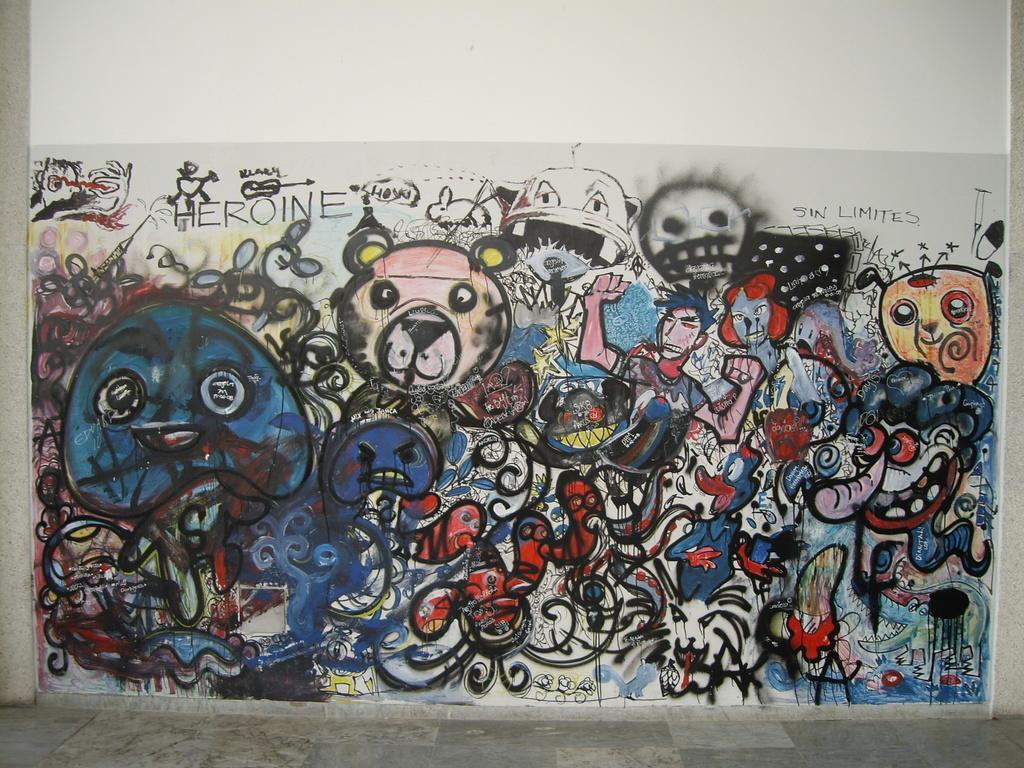How would you summarize this image in a sentence or two? In this image there is a painting on the wall with some text written on it. 